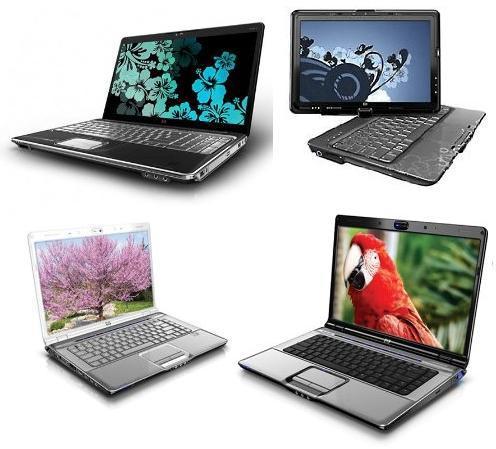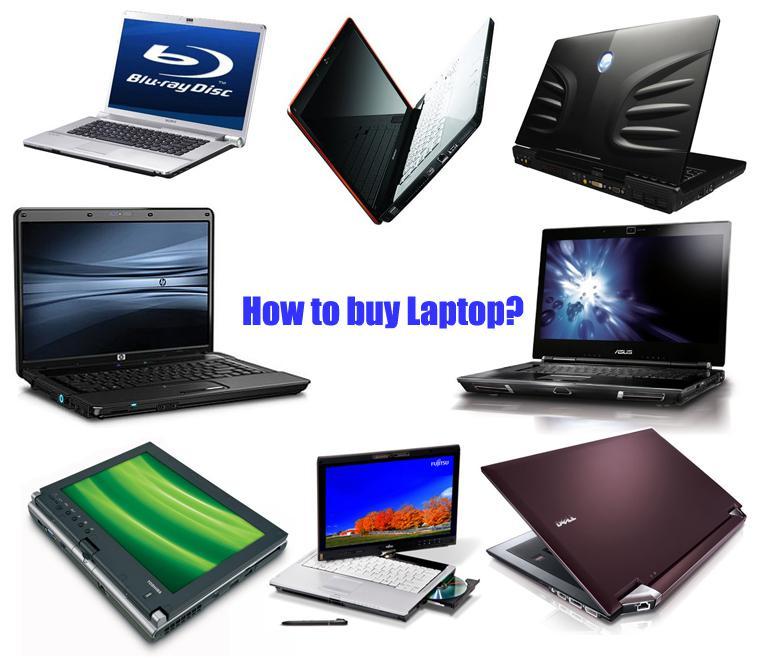The first image is the image on the left, the second image is the image on the right. Examine the images to the left and right. Is the description "There is an image of a bird on the screen of one of the computers in the image on the left." accurate? Answer yes or no. Yes. 